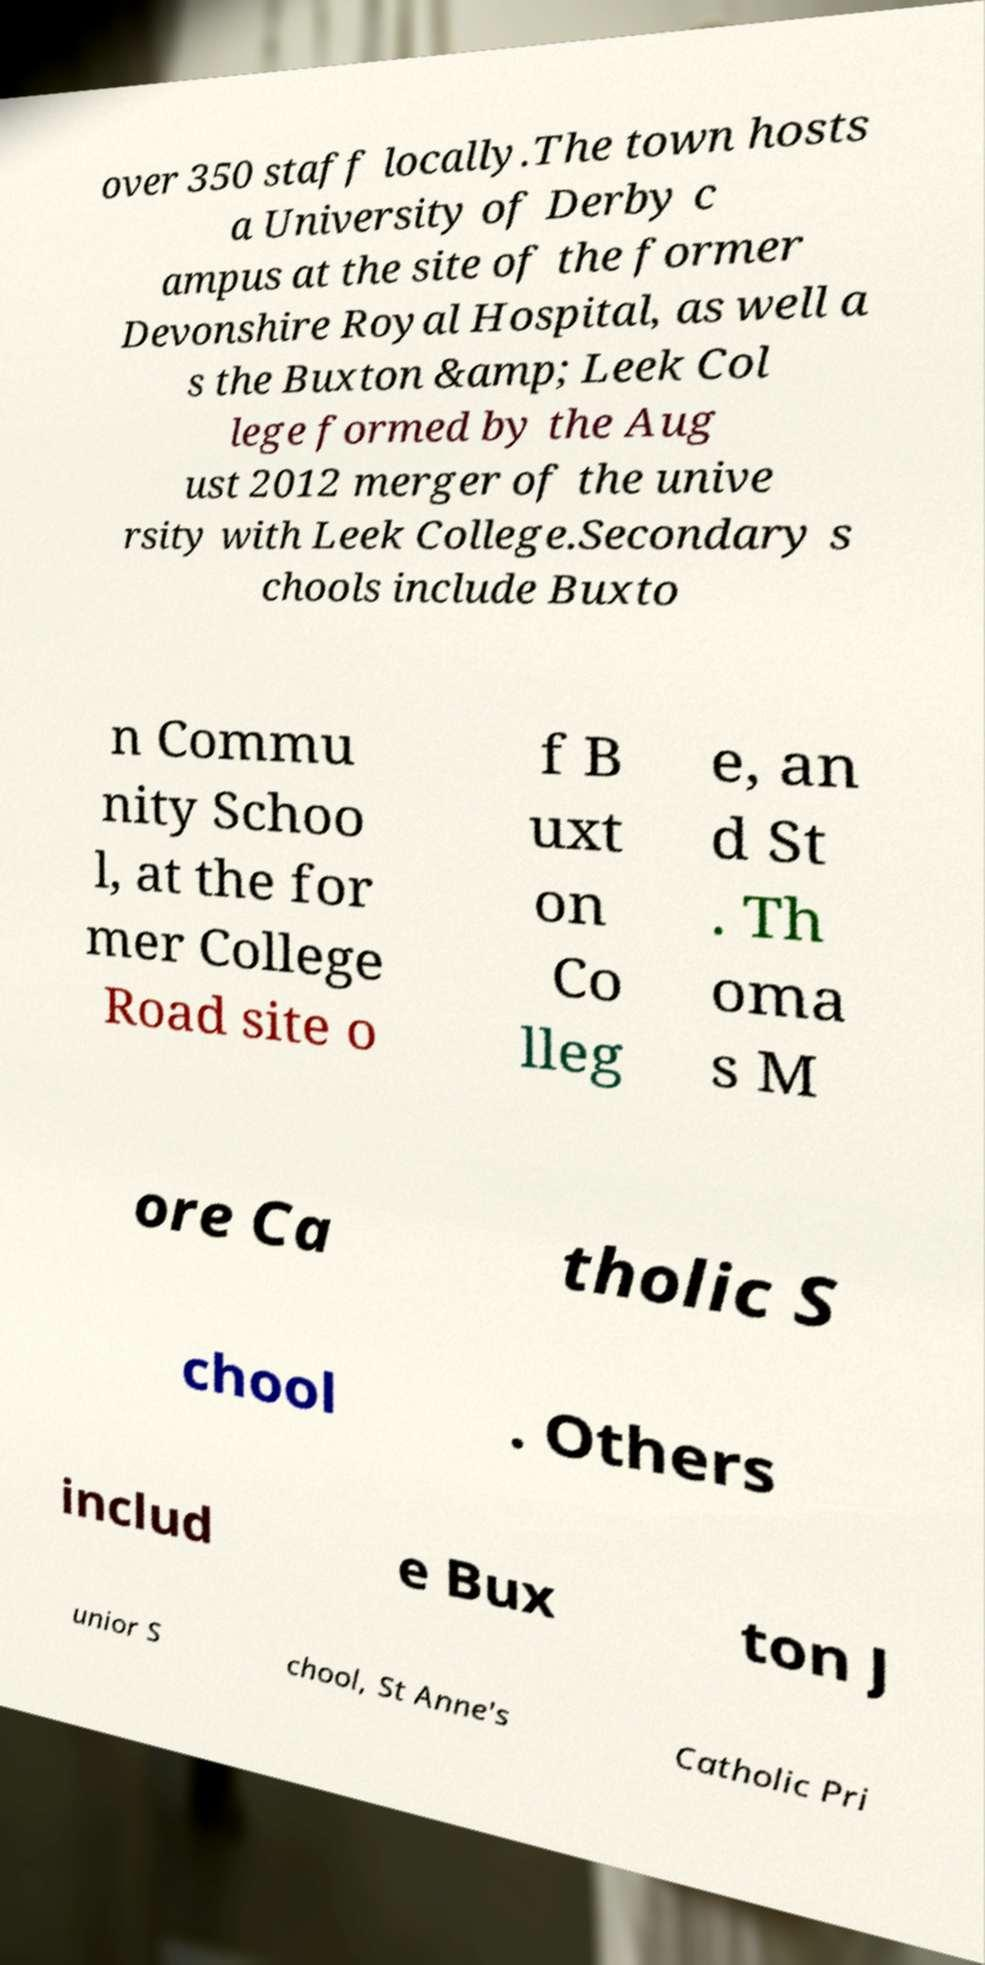There's text embedded in this image that I need extracted. Can you transcribe it verbatim? over 350 staff locally.The town hosts a University of Derby c ampus at the site of the former Devonshire Royal Hospital, as well a s the Buxton &amp; Leek Col lege formed by the Aug ust 2012 merger of the unive rsity with Leek College.Secondary s chools include Buxto n Commu nity Schoo l, at the for mer College Road site o f B uxt on Co lleg e, an d St . Th oma s M ore Ca tholic S chool . Others includ e Bux ton J unior S chool, St Anne's Catholic Pri 